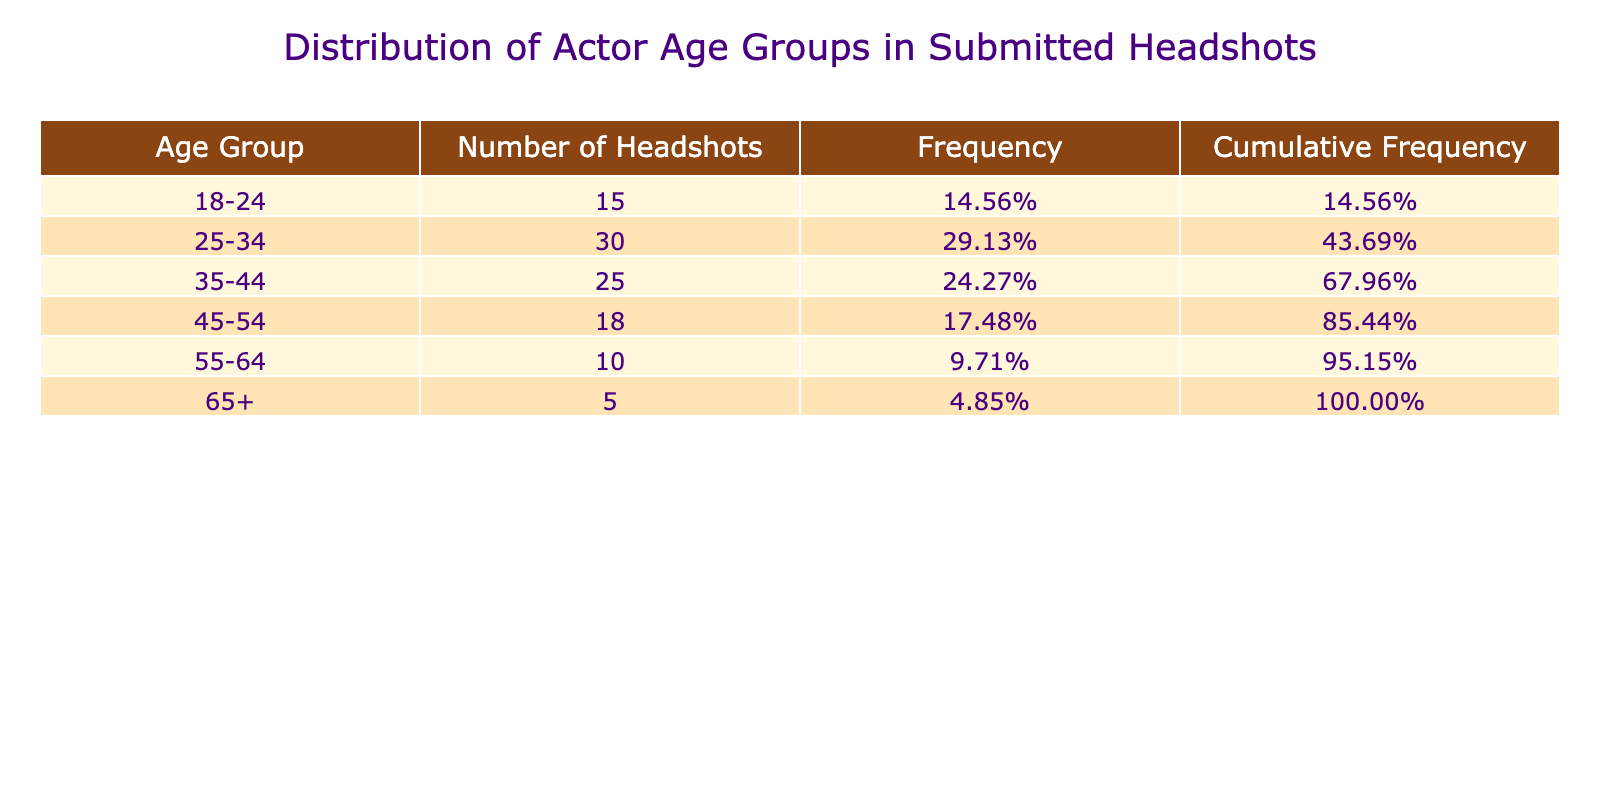What is the total number of headshots submitted in the age group 25-34? To find the total number of headshots in the age group 25-34, we can directly refer to the table where it lists 30 headshots in that group.
Answer: 30 What percentage of the headshots belong to the age group 18-24? The total number of headshots is 133 (sum of all headshots). The number of headshots in the 18-24 age group is 15, so the percentage is (15/133) * 100 which equals approximately 11.29%.
Answer: Approximately 11.29% Which age group has the highest number of submitted headshots? By observing the table, it shows that the age group 25-34 has the highest number of headshots at 30.
Answer: 25-34 Is there a greater number of headshots in the age group 45-54 than in the 55-64 age group? The age group 45-54 has 18 headshots while the 55-64 age group has 10 headshots. Since 18 is greater than 10, the answer is yes.
Answer: Yes What is the cumulative frequency for the age group 35-44? To calculate the cumulative frequency for the age group 35-44, we add the frequencies of all preceding age groups: 15 (18-24) + 30 (25-34) + 25 (35-44) = 70. The cumulative frequency for 35-44 at this point is 70/133 which equals approximately 52.63%.
Answer: Approximately 52.63% What is the difference between the number of headshots in the age group 35-44 and the age group 55-64? The number of headshots in the age group 35-44 is 25, and in the age group 55-64, it is 10. The difference is calculated as 25 - 10 = 15.
Answer: 15 Is the total number of headshots for age groups 45-54 and 65+ combined greater than those for age groups 18-24 and 25-34 combined? The summed number of headshots for the age groups 45-54 and 65+ is 18 + 5 = 23. The headshots for the 18-24 and 25-34 combined is 15 + 30 = 45. Since 23 is less than 45, the answer is no.
Answer: No What is the average number of headshots across all age groups? To find the average, we total up all the headshots which is 133 and divide by the number of age groups (6). Therefore, the average = 133 / 6, which equals approximately 22.17.
Answer: Approximately 22.17 Which age group has a frequency greater than 20%? We can determine frequency by finding the number of headshots divided by the total (133). For age groups: 18-24 (11.29%), 25-34 (22.56%), 35-44 (18.80%), 45-54 (13.53%), 55-64 (7.52%), and 65+ (3.76%). Only the age group 25-34 has a frequency greater than 20%.
Answer: 25-34 